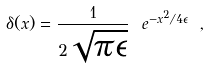Convert formula to latex. <formula><loc_0><loc_0><loc_500><loc_500>\delta ( x ) = \frac { 1 } { 2 \sqrt { \pi \epsilon } } \ e ^ { - x ^ { 2 } / 4 \epsilon } \ ,</formula> 